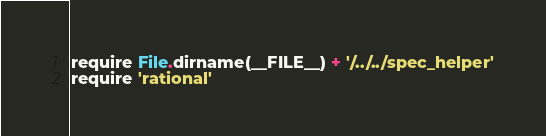Convert code to text. <code><loc_0><loc_0><loc_500><loc_500><_Ruby_>require File.dirname(__FILE__) + '/../../spec_helper'
require 'rational'
</code> 